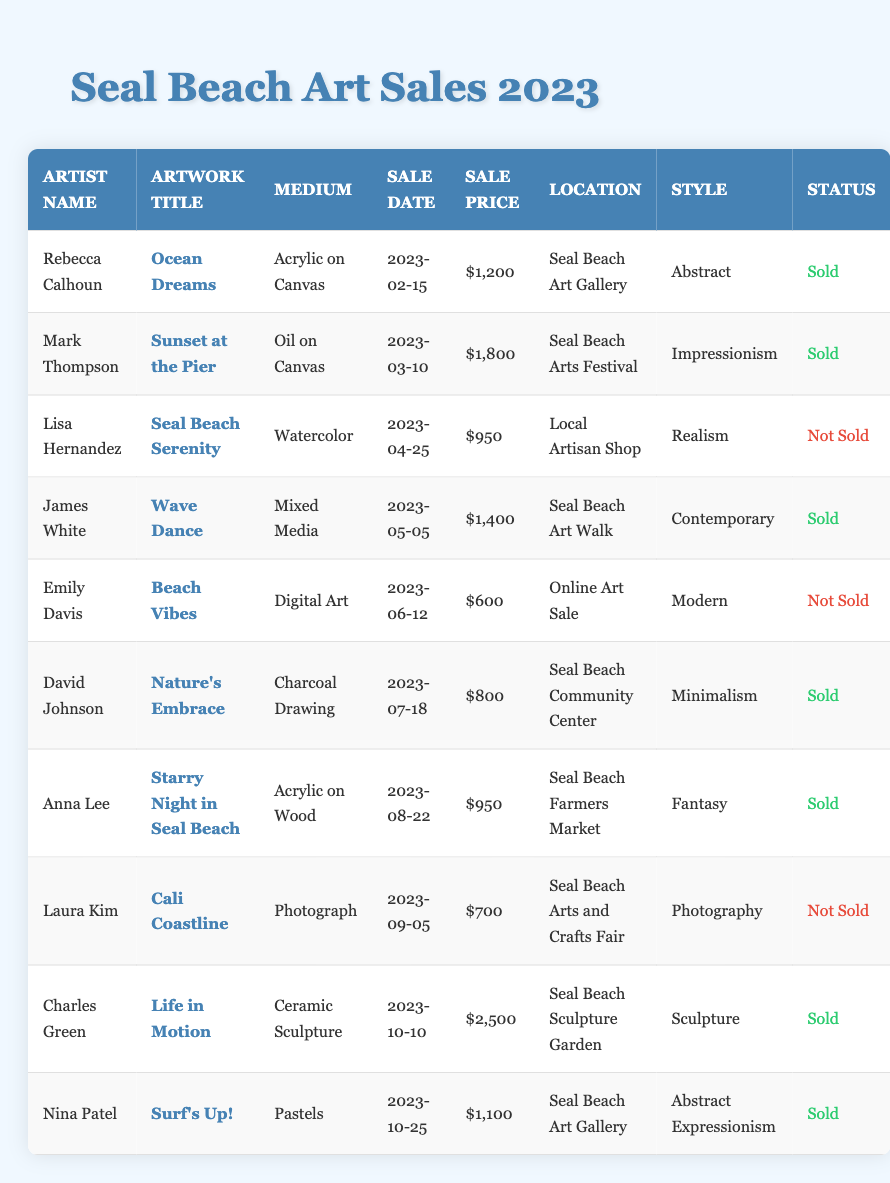What is the title of the artwork sold on March 10, 2023? The table indicates that on March 10, 2023, Mark Thompson sold an artwork titled "Sunset at the Pier."
Answer: Sunset at the Pier How many artworks were sold in total? By scanning through the table, I can identify that there are 6 sold artworks listed, which are marked as "Sold" in the status column.
Answer: 6 What is the sale price of the most expensive artwork? Looking at the sale prices in the table, I find that "Life in Motion" by Charles Green is priced at $2,500, which is the highest among all artworks.
Answer: $2,500 Which artist had a sale on April 25, 2023? According to the table, Lisa Hernandez had an artwork titled "Seal Beach Serenity" that was for sale on April 25, 2023, but it was not sold.
Answer: Lisa Hernandez Did any artwork sell for less than $1,000? By reviewing the sale prices in the table, Emily Davis's "Beach Vibes" sold for $600, which is indeed less than $1,000.
Answer: Yes What is the average sale price of sold artworks? The sale prices of sold artworks are $1,200, $1,800, $1,400, $800, $2,500, and $1,100. I calculate the total as $1,200 + $1,800 + $1,400 + $800 + $2,500 + $1,100 = $9,800, and divide by 6 (the number of sold artworks) to find the average price of $1,633.33.
Answer: $1,633.33 Which location had the most artworks sold? By reviewing the table, I see that three artworks were sold at the Seal Beach Art Gallery and one each at several other locations. Hence, Seal Beach Art Gallery had the highest count of sold artworks.
Answer: Seal Beach Art Gallery What style of art was sold most frequently? Analyzing the styles for sold artworks, the styles are Abstract, Impressionism, Contemporary, Minimalism, Sculpture, and Abstract Expressionism. I have three different styles (two Abstract, one each of the others), thus the most frequent style is Abstract, as it appears the most often among the sold artworks.
Answer: Abstract Were there any artworks sold at the Seal Beach Community Center? According to the table, David Johnson's artwork "Nature’s Embrace" was sold at the Seal Beach Community Center.
Answer: Yes What is the total revenue generated from sold artworks? I sum the sale prices of all sold artworks: $1,200 + $1,800 + $1,400 + $800 + $2,500 + $1,100 = $9,800, which gives the total revenue from all sold artworks.
Answer: $9,800 